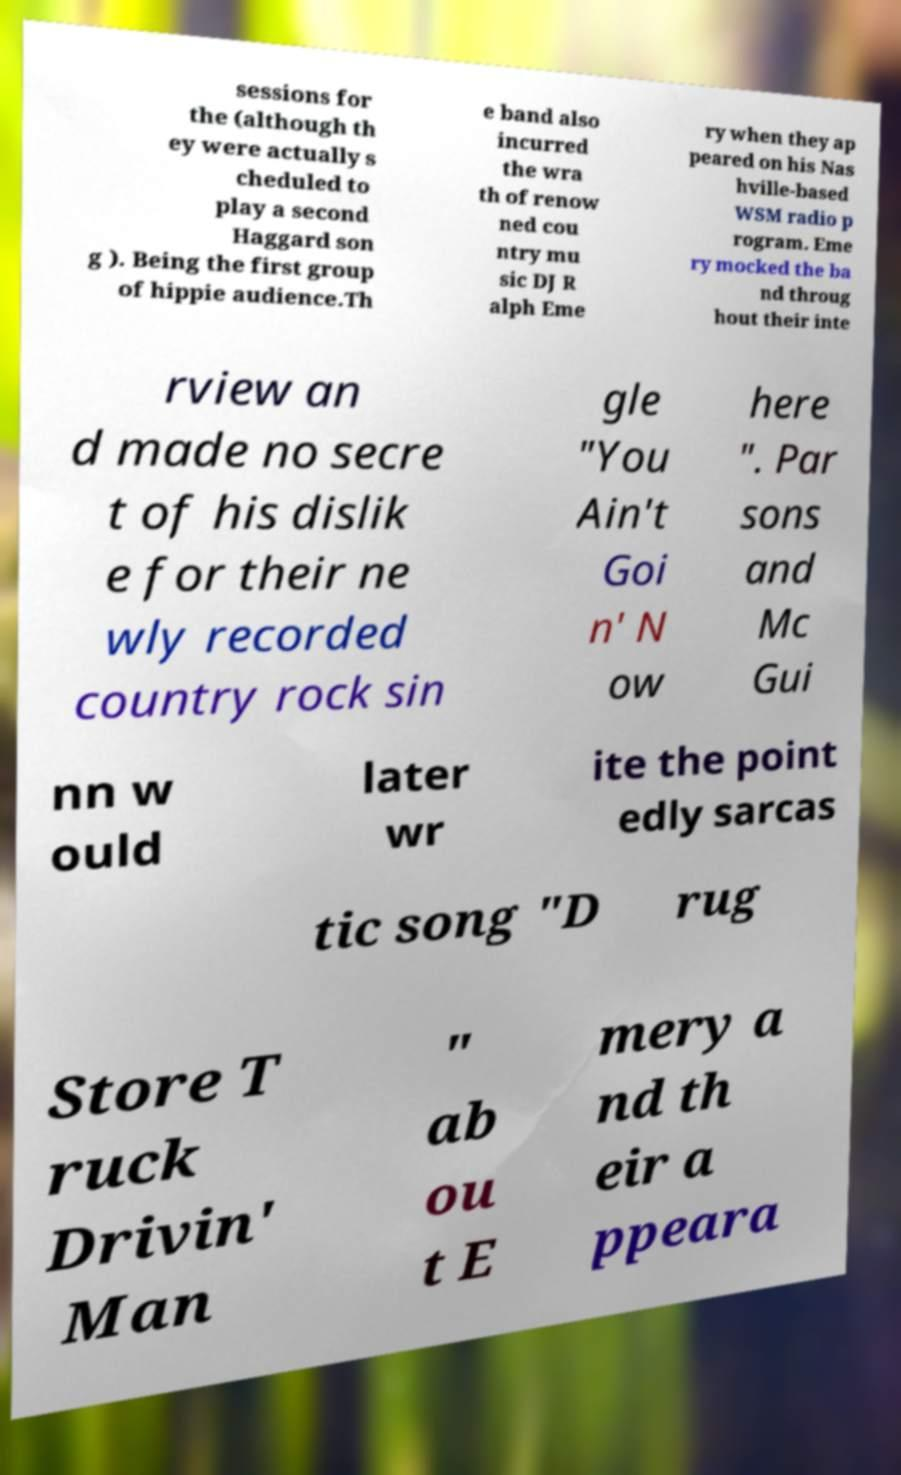Can you read and provide the text displayed in the image?This photo seems to have some interesting text. Can you extract and type it out for me? sessions for the (although th ey were actually s cheduled to play a second Haggard son g ). Being the first group of hippie audience.Th e band also incurred the wra th of renow ned cou ntry mu sic DJ R alph Eme ry when they ap peared on his Nas hville-based WSM radio p rogram. Eme ry mocked the ba nd throug hout their inte rview an d made no secre t of his dislik e for their ne wly recorded country rock sin gle "You Ain't Goi n' N ow here ". Par sons and Mc Gui nn w ould later wr ite the point edly sarcas tic song "D rug Store T ruck Drivin' Man " ab ou t E mery a nd th eir a ppeara 